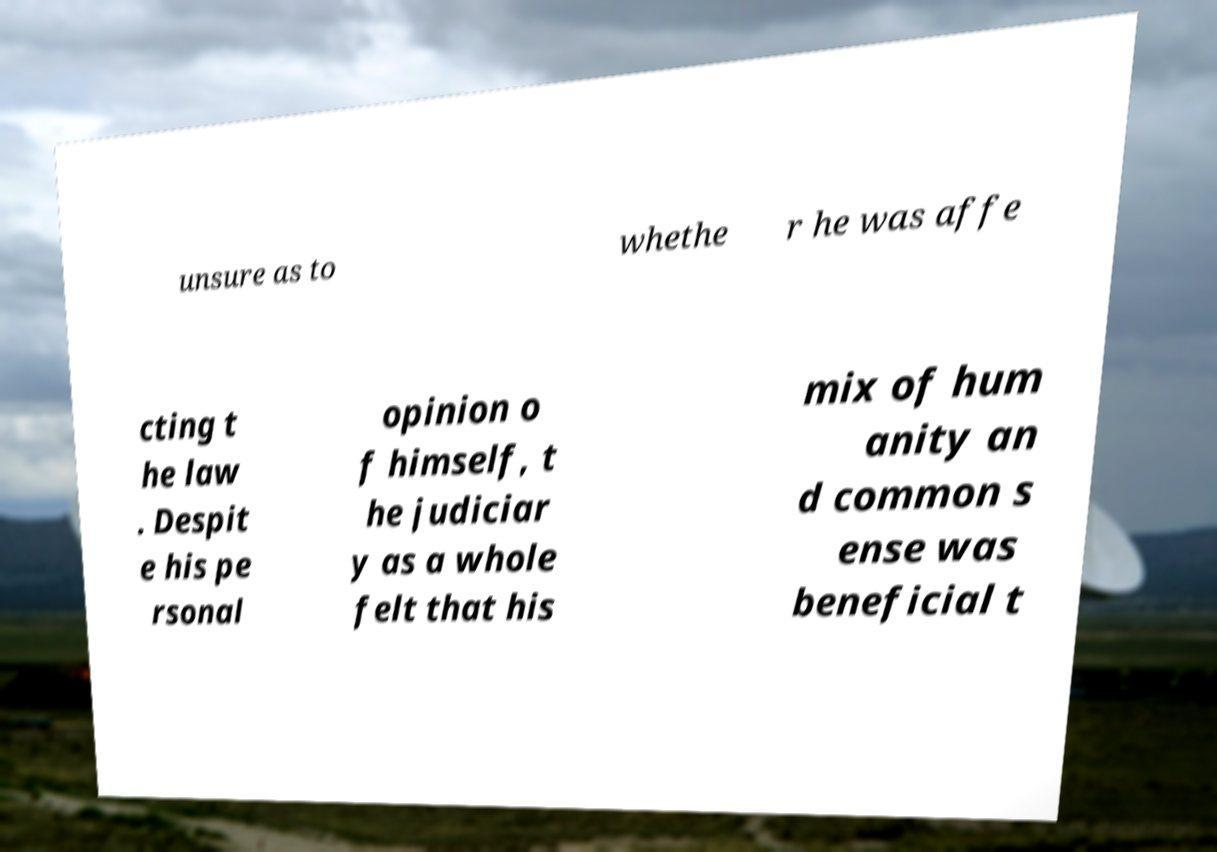Can you read and provide the text displayed in the image?This photo seems to have some interesting text. Can you extract and type it out for me? unsure as to whethe r he was affe cting t he law . Despit e his pe rsonal opinion o f himself, t he judiciar y as a whole felt that his mix of hum anity an d common s ense was beneficial t 